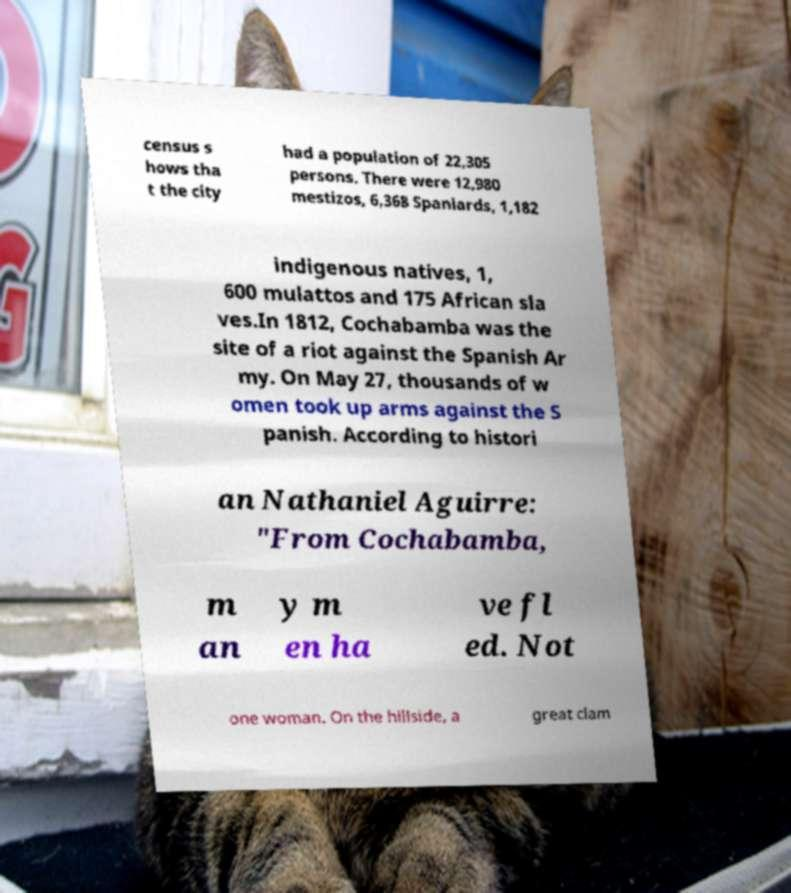Can you accurately transcribe the text from the provided image for me? census s hows tha t the city had a population of 22,305 persons. There were 12,980 mestizos, 6,368 Spaniards, 1,182 indigenous natives, 1, 600 mulattos and 175 African sla ves.In 1812, Cochabamba was the site of a riot against the Spanish Ar my. On May 27, thousands of w omen took up arms against the S panish. According to histori an Nathaniel Aguirre: "From Cochabamba, m an y m en ha ve fl ed. Not one woman. On the hillside, a great clam 